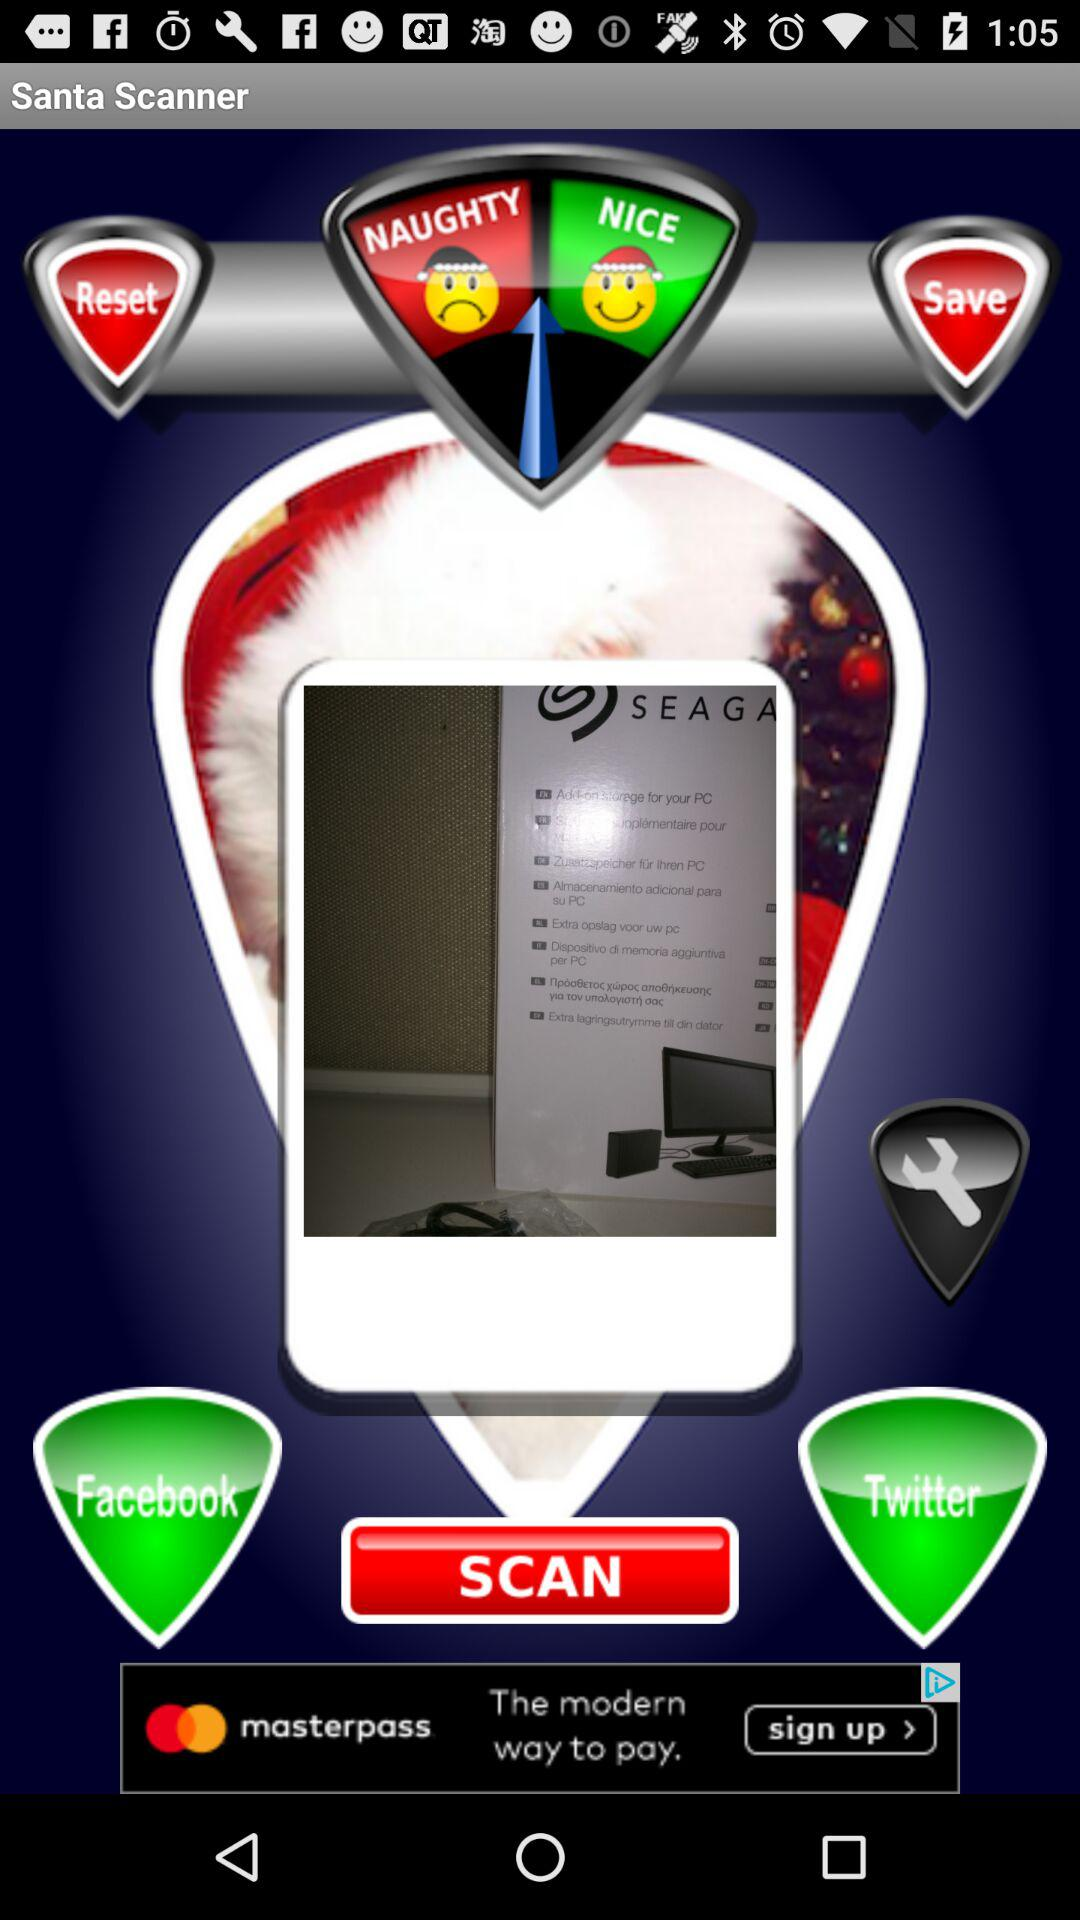What is the name of the application? The name of the application is "Santa Scanner". 